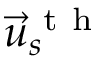Convert formula to latex. <formula><loc_0><loc_0><loc_500><loc_500>\vec { u } _ { s } ^ { t h }</formula> 